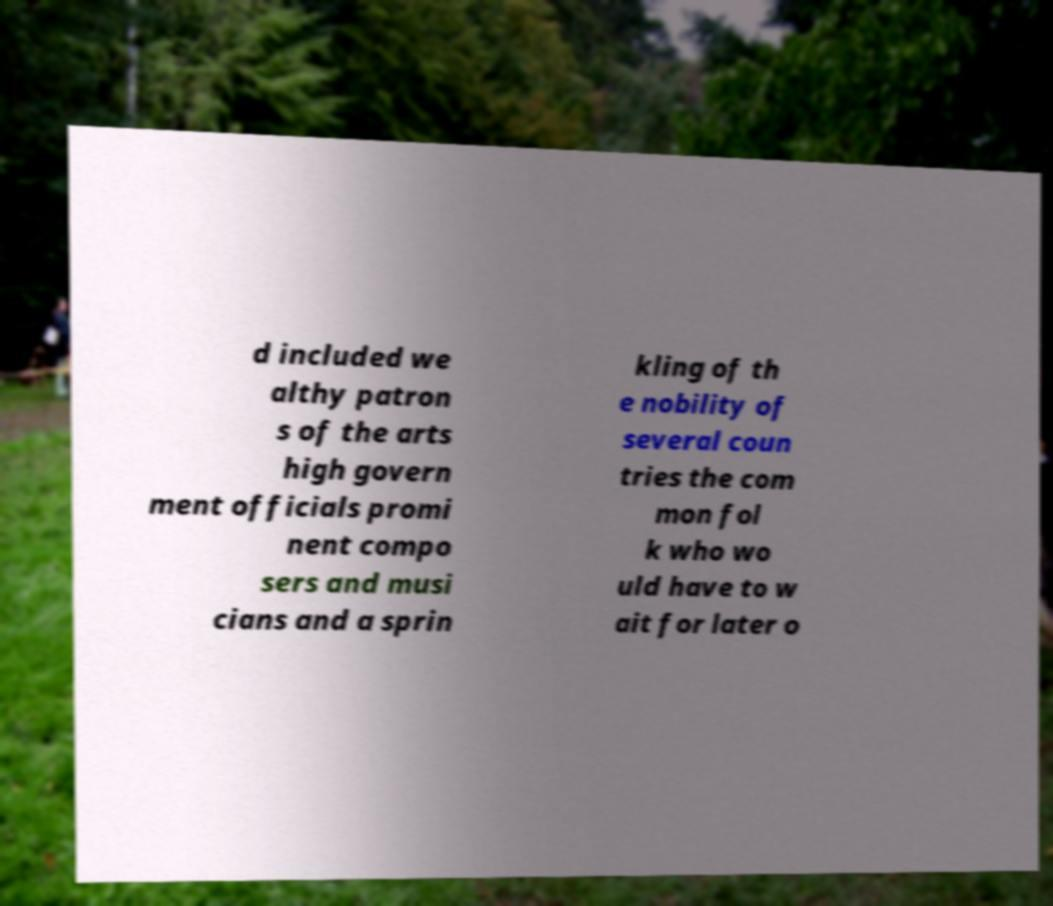Could you assist in decoding the text presented in this image and type it out clearly? d included we althy patron s of the arts high govern ment officials promi nent compo sers and musi cians and a sprin kling of th e nobility of several coun tries the com mon fol k who wo uld have to w ait for later o 